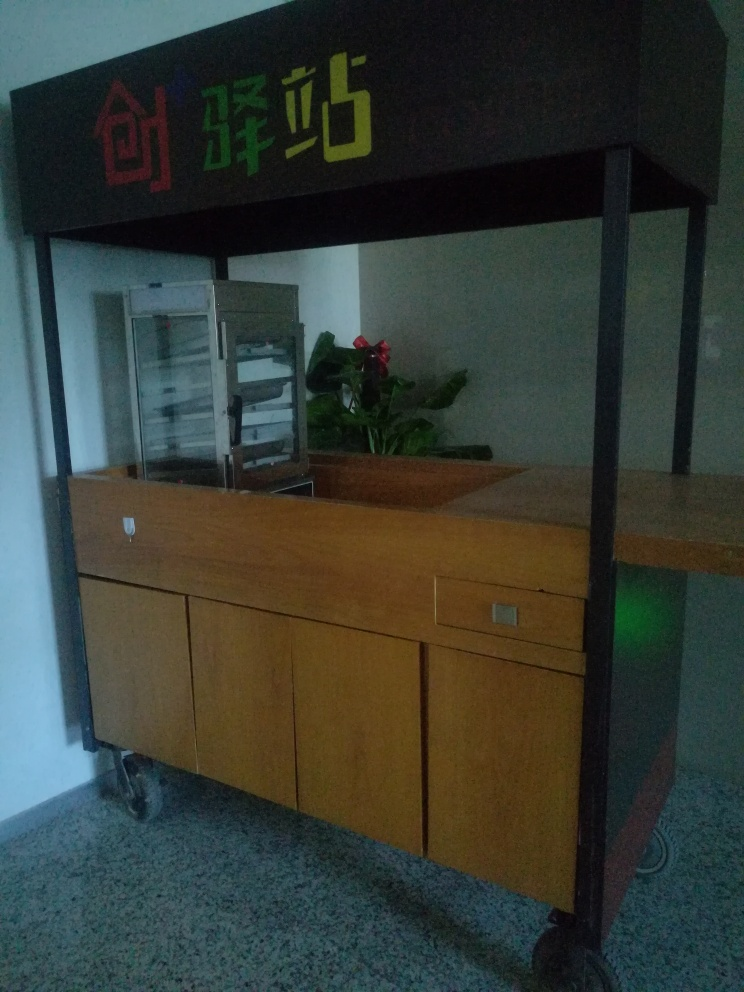Are the texture details of the table well-captured? The texture details of the table are moderately captured, with the image showing some level of grain detail on the wooden surface. However, the lower lighting conditions result in a loss of finer texture nuances that could have made the details more pronounced and visible. 